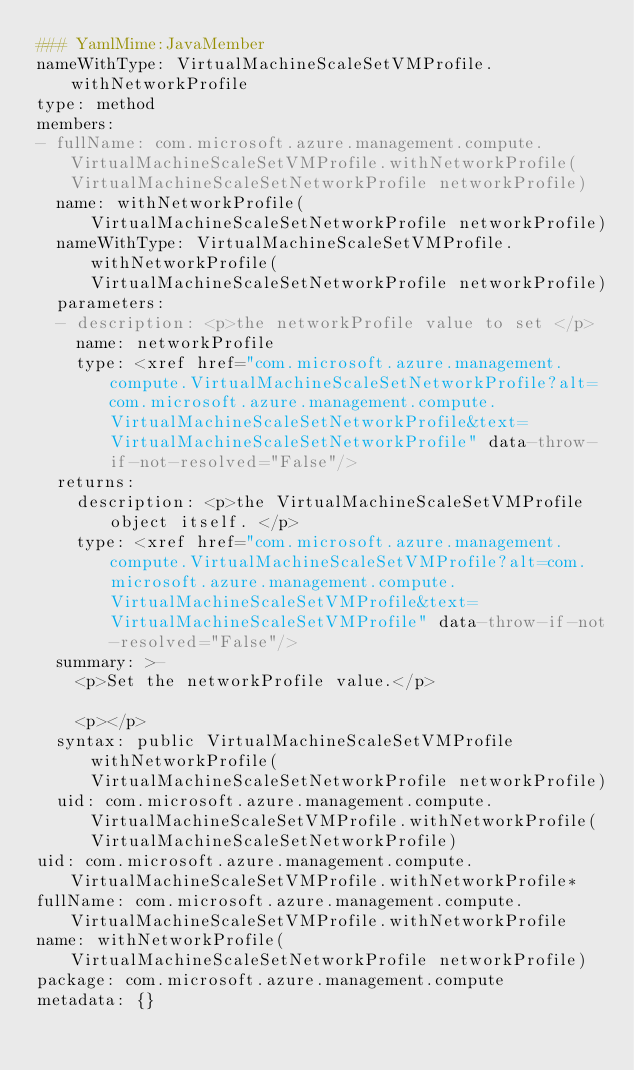Convert code to text. <code><loc_0><loc_0><loc_500><loc_500><_YAML_>### YamlMime:JavaMember
nameWithType: VirtualMachineScaleSetVMProfile.withNetworkProfile
type: method
members:
- fullName: com.microsoft.azure.management.compute.VirtualMachineScaleSetVMProfile.withNetworkProfile(VirtualMachineScaleSetNetworkProfile networkProfile)
  name: withNetworkProfile(VirtualMachineScaleSetNetworkProfile networkProfile)
  nameWithType: VirtualMachineScaleSetVMProfile.withNetworkProfile(VirtualMachineScaleSetNetworkProfile networkProfile)
  parameters:
  - description: <p>the networkProfile value to set </p>
    name: networkProfile
    type: <xref href="com.microsoft.azure.management.compute.VirtualMachineScaleSetNetworkProfile?alt=com.microsoft.azure.management.compute.VirtualMachineScaleSetNetworkProfile&text=VirtualMachineScaleSetNetworkProfile" data-throw-if-not-resolved="False"/>
  returns:
    description: <p>the VirtualMachineScaleSetVMProfile object itself. </p>
    type: <xref href="com.microsoft.azure.management.compute.VirtualMachineScaleSetVMProfile?alt=com.microsoft.azure.management.compute.VirtualMachineScaleSetVMProfile&text=VirtualMachineScaleSetVMProfile" data-throw-if-not-resolved="False"/>
  summary: >-
    <p>Set the networkProfile value.</p>

    <p></p>
  syntax: public VirtualMachineScaleSetVMProfile withNetworkProfile(VirtualMachineScaleSetNetworkProfile networkProfile)
  uid: com.microsoft.azure.management.compute.VirtualMachineScaleSetVMProfile.withNetworkProfile(VirtualMachineScaleSetNetworkProfile)
uid: com.microsoft.azure.management.compute.VirtualMachineScaleSetVMProfile.withNetworkProfile*
fullName: com.microsoft.azure.management.compute.VirtualMachineScaleSetVMProfile.withNetworkProfile
name: withNetworkProfile(VirtualMachineScaleSetNetworkProfile networkProfile)
package: com.microsoft.azure.management.compute
metadata: {}
</code> 